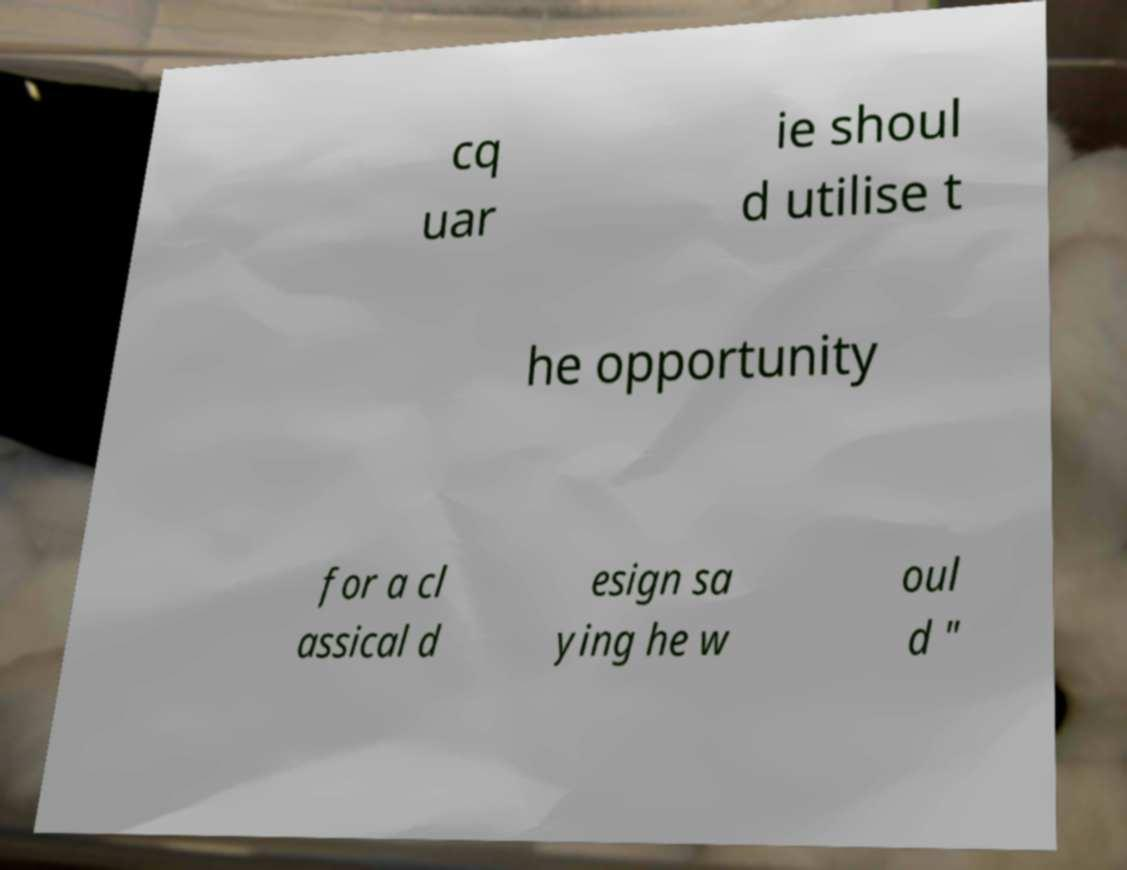I need the written content from this picture converted into text. Can you do that? cq uar ie shoul d utilise t he opportunity for a cl assical d esign sa ying he w oul d " 